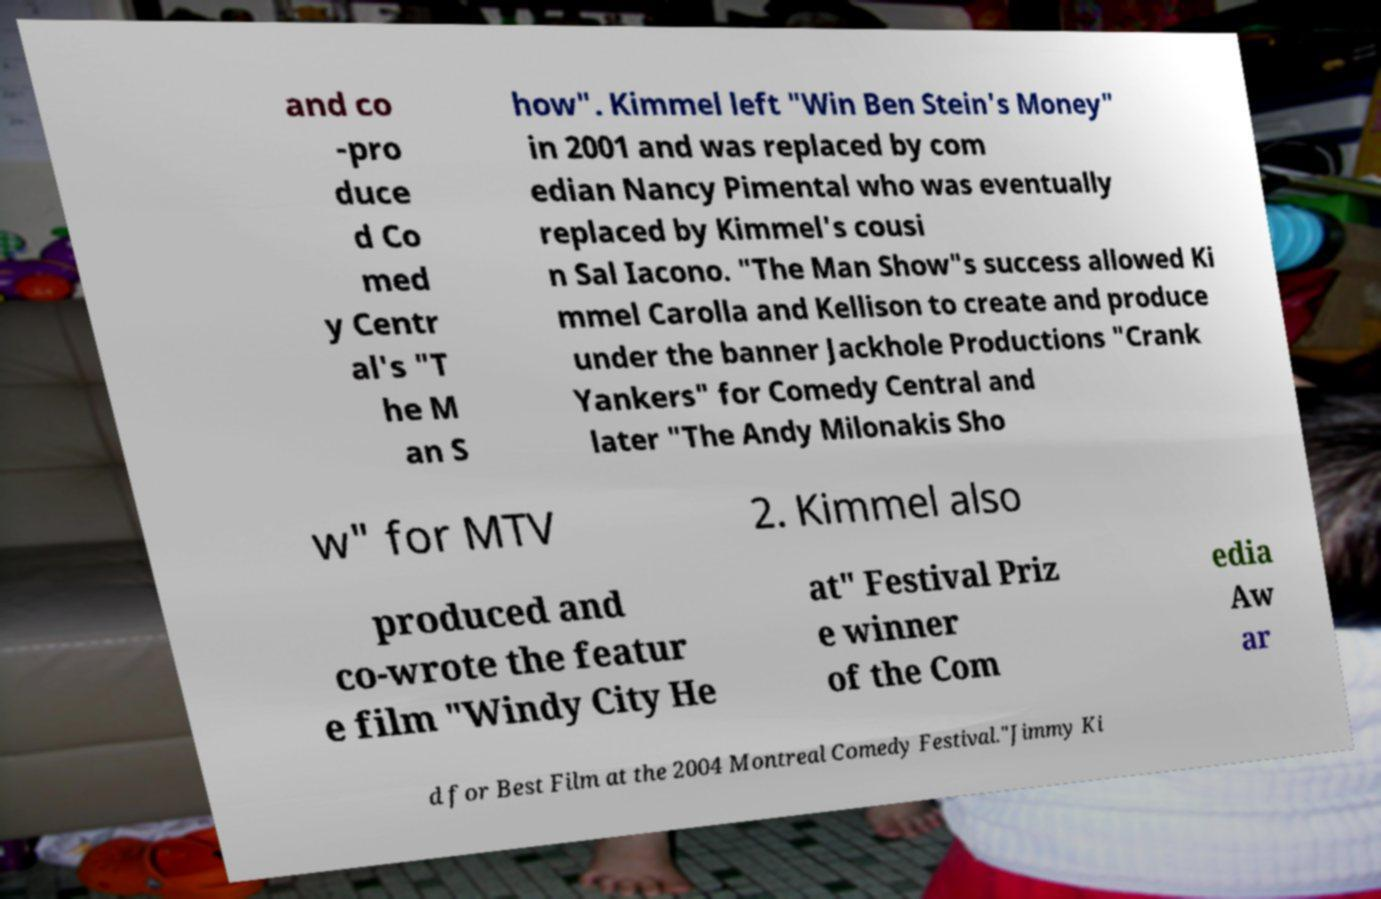Can you accurately transcribe the text from the provided image for me? and co -pro duce d Co med y Centr al's "T he M an S how". Kimmel left "Win Ben Stein's Money" in 2001 and was replaced by com edian Nancy Pimental who was eventually replaced by Kimmel's cousi n Sal Iacono. "The Man Show"s success allowed Ki mmel Carolla and Kellison to create and produce under the banner Jackhole Productions "Crank Yankers" for Comedy Central and later "The Andy Milonakis Sho w" for MTV 2. Kimmel also produced and co-wrote the featur e film "Windy City He at" Festival Priz e winner of the Com edia Aw ar d for Best Film at the 2004 Montreal Comedy Festival."Jimmy Ki 